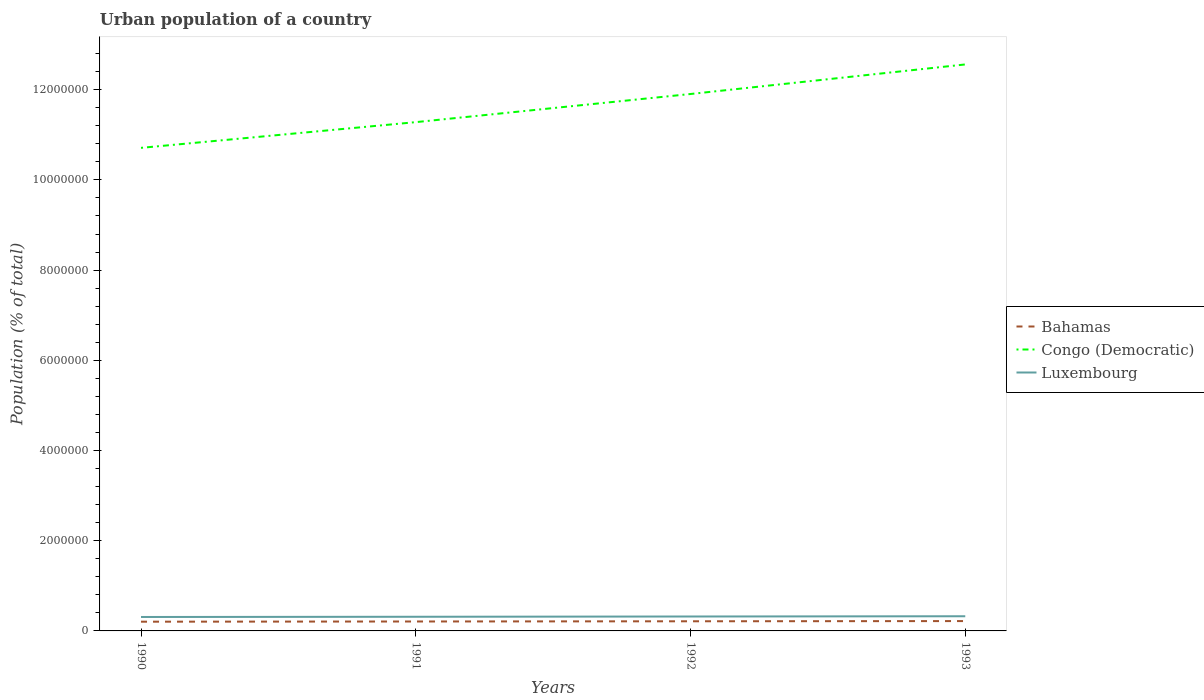How many different coloured lines are there?
Provide a short and direct response. 3. Does the line corresponding to Luxembourg intersect with the line corresponding to Bahamas?
Ensure brevity in your answer.  No. Is the number of lines equal to the number of legend labels?
Offer a terse response. Yes. Across all years, what is the maximum urban population in Bahamas?
Ensure brevity in your answer.  2.05e+05. In which year was the urban population in Congo (Democratic) maximum?
Give a very brief answer. 1990. What is the total urban population in Bahamas in the graph?
Offer a very short reply. -9031. What is the difference between the highest and the second highest urban population in Bahamas?
Ensure brevity in your answer.  1.37e+04. What is the difference between the highest and the lowest urban population in Bahamas?
Make the answer very short. 2. Is the urban population in Luxembourg strictly greater than the urban population in Congo (Democratic) over the years?
Your answer should be compact. Yes. Are the values on the major ticks of Y-axis written in scientific E-notation?
Make the answer very short. No. Does the graph contain any zero values?
Your answer should be compact. No. How are the legend labels stacked?
Give a very brief answer. Vertical. What is the title of the graph?
Your answer should be compact. Urban population of a country. Does "Cyprus" appear as one of the legend labels in the graph?
Offer a very short reply. No. What is the label or title of the Y-axis?
Provide a short and direct response. Population (% of total). What is the Population (% of total) of Bahamas in 1990?
Give a very brief answer. 2.05e+05. What is the Population (% of total) of Congo (Democratic) in 1990?
Provide a short and direct response. 1.07e+07. What is the Population (% of total) of Luxembourg in 1990?
Make the answer very short. 3.09e+05. What is the Population (% of total) of Bahamas in 1991?
Provide a short and direct response. 2.09e+05. What is the Population (% of total) in Congo (Democratic) in 1991?
Make the answer very short. 1.13e+07. What is the Population (% of total) of Luxembourg in 1991?
Keep it short and to the point. 3.14e+05. What is the Population (% of total) in Bahamas in 1992?
Keep it short and to the point. 2.14e+05. What is the Population (% of total) in Congo (Democratic) in 1992?
Provide a short and direct response. 1.19e+07. What is the Population (% of total) of Luxembourg in 1992?
Make the answer very short. 3.20e+05. What is the Population (% of total) of Bahamas in 1993?
Keep it short and to the point. 2.18e+05. What is the Population (% of total) of Congo (Democratic) in 1993?
Provide a short and direct response. 1.26e+07. What is the Population (% of total) of Luxembourg in 1993?
Offer a very short reply. 3.25e+05. Across all years, what is the maximum Population (% of total) of Bahamas?
Provide a short and direct response. 2.18e+05. Across all years, what is the maximum Population (% of total) of Congo (Democratic)?
Give a very brief answer. 1.26e+07. Across all years, what is the maximum Population (% of total) in Luxembourg?
Make the answer very short. 3.25e+05. Across all years, what is the minimum Population (% of total) in Bahamas?
Give a very brief answer. 2.05e+05. Across all years, what is the minimum Population (% of total) in Congo (Democratic)?
Offer a terse response. 1.07e+07. Across all years, what is the minimum Population (% of total) of Luxembourg?
Make the answer very short. 3.09e+05. What is the total Population (% of total) in Bahamas in the graph?
Keep it short and to the point. 8.46e+05. What is the total Population (% of total) in Congo (Democratic) in the graph?
Your answer should be compact. 4.65e+07. What is the total Population (% of total) in Luxembourg in the graph?
Offer a very short reply. 1.27e+06. What is the difference between the Population (% of total) of Bahamas in 1990 and that in 1991?
Provide a short and direct response. -4414. What is the difference between the Population (% of total) in Congo (Democratic) in 1990 and that in 1991?
Give a very brief answer. -5.70e+05. What is the difference between the Population (% of total) in Luxembourg in 1990 and that in 1991?
Ensure brevity in your answer.  -4877. What is the difference between the Population (% of total) of Bahamas in 1990 and that in 1992?
Provide a succinct answer. -9031. What is the difference between the Population (% of total) of Congo (Democratic) in 1990 and that in 1992?
Your answer should be very brief. -1.19e+06. What is the difference between the Population (% of total) in Luxembourg in 1990 and that in 1992?
Keep it short and to the point. -1.06e+04. What is the difference between the Population (% of total) in Bahamas in 1990 and that in 1993?
Provide a short and direct response. -1.37e+04. What is the difference between the Population (% of total) in Congo (Democratic) in 1990 and that in 1993?
Provide a succinct answer. -1.85e+06. What is the difference between the Population (% of total) of Luxembourg in 1990 and that in 1993?
Ensure brevity in your answer.  -1.63e+04. What is the difference between the Population (% of total) of Bahamas in 1991 and that in 1992?
Provide a succinct answer. -4617. What is the difference between the Population (% of total) in Congo (Democratic) in 1991 and that in 1992?
Provide a short and direct response. -6.24e+05. What is the difference between the Population (% of total) of Luxembourg in 1991 and that in 1992?
Ensure brevity in your answer.  -5759. What is the difference between the Population (% of total) of Bahamas in 1991 and that in 1993?
Provide a succinct answer. -9268. What is the difference between the Population (% of total) in Congo (Democratic) in 1991 and that in 1993?
Provide a succinct answer. -1.28e+06. What is the difference between the Population (% of total) of Luxembourg in 1991 and that in 1993?
Offer a terse response. -1.14e+04. What is the difference between the Population (% of total) of Bahamas in 1992 and that in 1993?
Your answer should be compact. -4651. What is the difference between the Population (% of total) of Congo (Democratic) in 1992 and that in 1993?
Give a very brief answer. -6.55e+05. What is the difference between the Population (% of total) of Luxembourg in 1992 and that in 1993?
Provide a short and direct response. -5629. What is the difference between the Population (% of total) of Bahamas in 1990 and the Population (% of total) of Congo (Democratic) in 1991?
Make the answer very short. -1.11e+07. What is the difference between the Population (% of total) in Bahamas in 1990 and the Population (% of total) in Luxembourg in 1991?
Provide a succinct answer. -1.09e+05. What is the difference between the Population (% of total) in Congo (Democratic) in 1990 and the Population (% of total) in Luxembourg in 1991?
Your answer should be compact. 1.04e+07. What is the difference between the Population (% of total) in Bahamas in 1990 and the Population (% of total) in Congo (Democratic) in 1992?
Give a very brief answer. -1.17e+07. What is the difference between the Population (% of total) in Bahamas in 1990 and the Population (% of total) in Luxembourg in 1992?
Make the answer very short. -1.15e+05. What is the difference between the Population (% of total) of Congo (Democratic) in 1990 and the Population (% of total) of Luxembourg in 1992?
Your answer should be compact. 1.04e+07. What is the difference between the Population (% of total) in Bahamas in 1990 and the Population (% of total) in Congo (Democratic) in 1993?
Your answer should be compact. -1.24e+07. What is the difference between the Population (% of total) of Bahamas in 1990 and the Population (% of total) of Luxembourg in 1993?
Give a very brief answer. -1.21e+05. What is the difference between the Population (% of total) of Congo (Democratic) in 1990 and the Population (% of total) of Luxembourg in 1993?
Provide a short and direct response. 1.04e+07. What is the difference between the Population (% of total) in Bahamas in 1991 and the Population (% of total) in Congo (Democratic) in 1992?
Offer a terse response. -1.17e+07. What is the difference between the Population (% of total) in Bahamas in 1991 and the Population (% of total) in Luxembourg in 1992?
Keep it short and to the point. -1.11e+05. What is the difference between the Population (% of total) in Congo (Democratic) in 1991 and the Population (% of total) in Luxembourg in 1992?
Give a very brief answer. 1.10e+07. What is the difference between the Population (% of total) in Bahamas in 1991 and the Population (% of total) in Congo (Democratic) in 1993?
Your response must be concise. -1.24e+07. What is the difference between the Population (% of total) in Bahamas in 1991 and the Population (% of total) in Luxembourg in 1993?
Keep it short and to the point. -1.16e+05. What is the difference between the Population (% of total) in Congo (Democratic) in 1991 and the Population (% of total) in Luxembourg in 1993?
Provide a succinct answer. 1.10e+07. What is the difference between the Population (% of total) of Bahamas in 1992 and the Population (% of total) of Congo (Democratic) in 1993?
Your response must be concise. -1.23e+07. What is the difference between the Population (% of total) in Bahamas in 1992 and the Population (% of total) in Luxembourg in 1993?
Make the answer very short. -1.12e+05. What is the difference between the Population (% of total) in Congo (Democratic) in 1992 and the Population (% of total) in Luxembourg in 1993?
Give a very brief answer. 1.16e+07. What is the average Population (% of total) of Bahamas per year?
Keep it short and to the point. 2.11e+05. What is the average Population (% of total) of Congo (Democratic) per year?
Offer a terse response. 1.16e+07. What is the average Population (% of total) in Luxembourg per year?
Make the answer very short. 3.17e+05. In the year 1990, what is the difference between the Population (% of total) in Bahamas and Population (% of total) in Congo (Democratic)?
Ensure brevity in your answer.  -1.05e+07. In the year 1990, what is the difference between the Population (% of total) in Bahamas and Population (% of total) in Luxembourg?
Offer a very short reply. -1.04e+05. In the year 1990, what is the difference between the Population (% of total) in Congo (Democratic) and Population (% of total) in Luxembourg?
Your response must be concise. 1.04e+07. In the year 1991, what is the difference between the Population (% of total) of Bahamas and Population (% of total) of Congo (Democratic)?
Give a very brief answer. -1.11e+07. In the year 1991, what is the difference between the Population (% of total) of Bahamas and Population (% of total) of Luxembourg?
Provide a short and direct response. -1.05e+05. In the year 1991, what is the difference between the Population (% of total) of Congo (Democratic) and Population (% of total) of Luxembourg?
Provide a succinct answer. 1.10e+07. In the year 1992, what is the difference between the Population (% of total) in Bahamas and Population (% of total) in Congo (Democratic)?
Your answer should be very brief. -1.17e+07. In the year 1992, what is the difference between the Population (% of total) of Bahamas and Population (% of total) of Luxembourg?
Ensure brevity in your answer.  -1.06e+05. In the year 1992, what is the difference between the Population (% of total) in Congo (Democratic) and Population (% of total) in Luxembourg?
Offer a terse response. 1.16e+07. In the year 1993, what is the difference between the Population (% of total) of Bahamas and Population (% of total) of Congo (Democratic)?
Offer a terse response. -1.23e+07. In the year 1993, what is the difference between the Population (% of total) in Bahamas and Population (% of total) in Luxembourg?
Offer a terse response. -1.07e+05. In the year 1993, what is the difference between the Population (% of total) in Congo (Democratic) and Population (% of total) in Luxembourg?
Make the answer very short. 1.22e+07. What is the ratio of the Population (% of total) of Bahamas in 1990 to that in 1991?
Your answer should be very brief. 0.98. What is the ratio of the Population (% of total) of Congo (Democratic) in 1990 to that in 1991?
Provide a succinct answer. 0.95. What is the ratio of the Population (% of total) of Luxembourg in 1990 to that in 1991?
Give a very brief answer. 0.98. What is the ratio of the Population (% of total) of Bahamas in 1990 to that in 1992?
Your response must be concise. 0.96. What is the ratio of the Population (% of total) of Congo (Democratic) in 1990 to that in 1992?
Offer a very short reply. 0.9. What is the ratio of the Population (% of total) in Luxembourg in 1990 to that in 1992?
Give a very brief answer. 0.97. What is the ratio of the Population (% of total) of Bahamas in 1990 to that in 1993?
Your answer should be very brief. 0.94. What is the ratio of the Population (% of total) of Congo (Democratic) in 1990 to that in 1993?
Offer a very short reply. 0.85. What is the ratio of the Population (% of total) of Bahamas in 1991 to that in 1992?
Make the answer very short. 0.98. What is the ratio of the Population (% of total) of Congo (Democratic) in 1991 to that in 1992?
Your response must be concise. 0.95. What is the ratio of the Population (% of total) of Bahamas in 1991 to that in 1993?
Offer a terse response. 0.96. What is the ratio of the Population (% of total) in Congo (Democratic) in 1991 to that in 1993?
Ensure brevity in your answer.  0.9. What is the ratio of the Population (% of total) in Bahamas in 1992 to that in 1993?
Your answer should be compact. 0.98. What is the ratio of the Population (% of total) of Congo (Democratic) in 1992 to that in 1993?
Ensure brevity in your answer.  0.95. What is the ratio of the Population (% of total) in Luxembourg in 1992 to that in 1993?
Your answer should be compact. 0.98. What is the difference between the highest and the second highest Population (% of total) in Bahamas?
Your response must be concise. 4651. What is the difference between the highest and the second highest Population (% of total) in Congo (Democratic)?
Your answer should be very brief. 6.55e+05. What is the difference between the highest and the second highest Population (% of total) in Luxembourg?
Keep it short and to the point. 5629. What is the difference between the highest and the lowest Population (% of total) in Bahamas?
Give a very brief answer. 1.37e+04. What is the difference between the highest and the lowest Population (% of total) of Congo (Democratic)?
Your answer should be very brief. 1.85e+06. What is the difference between the highest and the lowest Population (% of total) of Luxembourg?
Your response must be concise. 1.63e+04. 